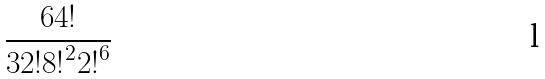<formula> <loc_0><loc_0><loc_500><loc_500>\frac { 6 4 ! } { 3 2 ! { 8 ! } ^ { 2 } { 2 ! } ^ { 6 } }</formula> 